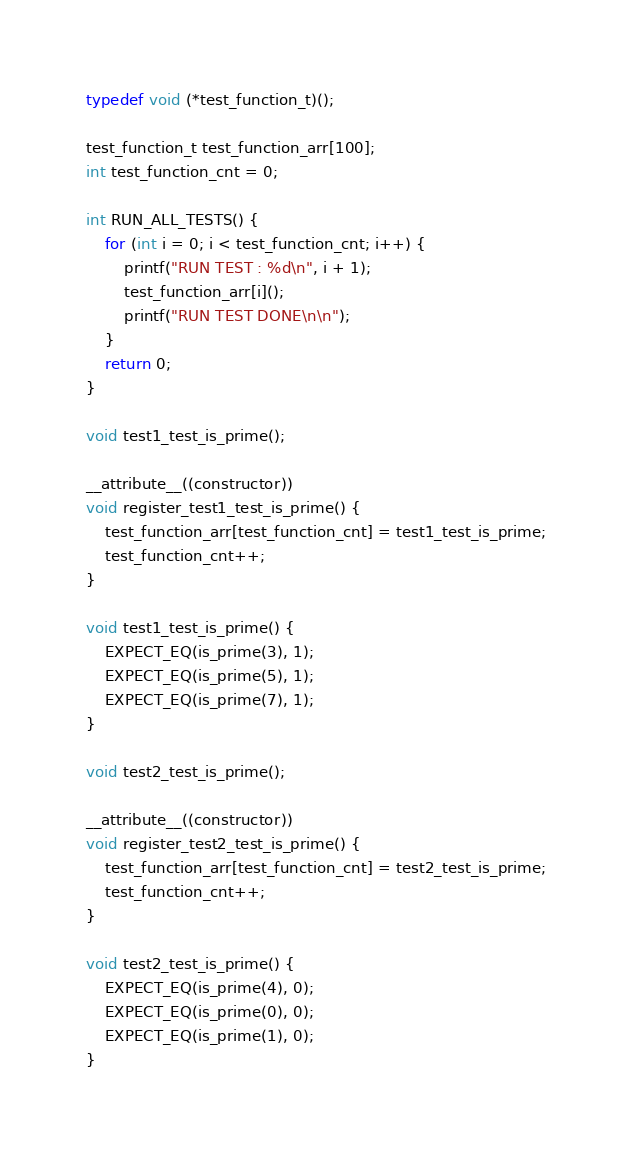<code> <loc_0><loc_0><loc_500><loc_500><_C_>typedef void (*test_function_t)();

test_function_t test_function_arr[100];
int test_function_cnt = 0;

int RUN_ALL_TESTS() {
    for (int i = 0; i < test_function_cnt; i++) {
        printf("RUN TEST : %d\n", i + 1);
        test_function_arr[i]();
        printf("RUN TEST DONE\n\n");
    }
    return 0;
}

void test1_test_is_prime();

__attribute__((constructor))
void register_test1_test_is_prime() {
    test_function_arr[test_function_cnt] = test1_test_is_prime; 
    test_function_cnt++;
}

void test1_test_is_prime() {
    EXPECT_EQ(is_prime(3), 1);
    EXPECT_EQ(is_prime(5), 1);
    EXPECT_EQ(is_prime(7), 1);
}

void test2_test_is_prime();

__attribute__((constructor))
void register_test2_test_is_prime() { 
    test_function_arr[test_function_cnt] = test2_test_is_prime; 
    test_function_cnt++;
}

void test2_test_is_prime() {
    EXPECT_EQ(is_prime(4), 0);
    EXPECT_EQ(is_prime(0), 0);
    EXPECT_EQ(is_prime(1), 0);
}</code> 